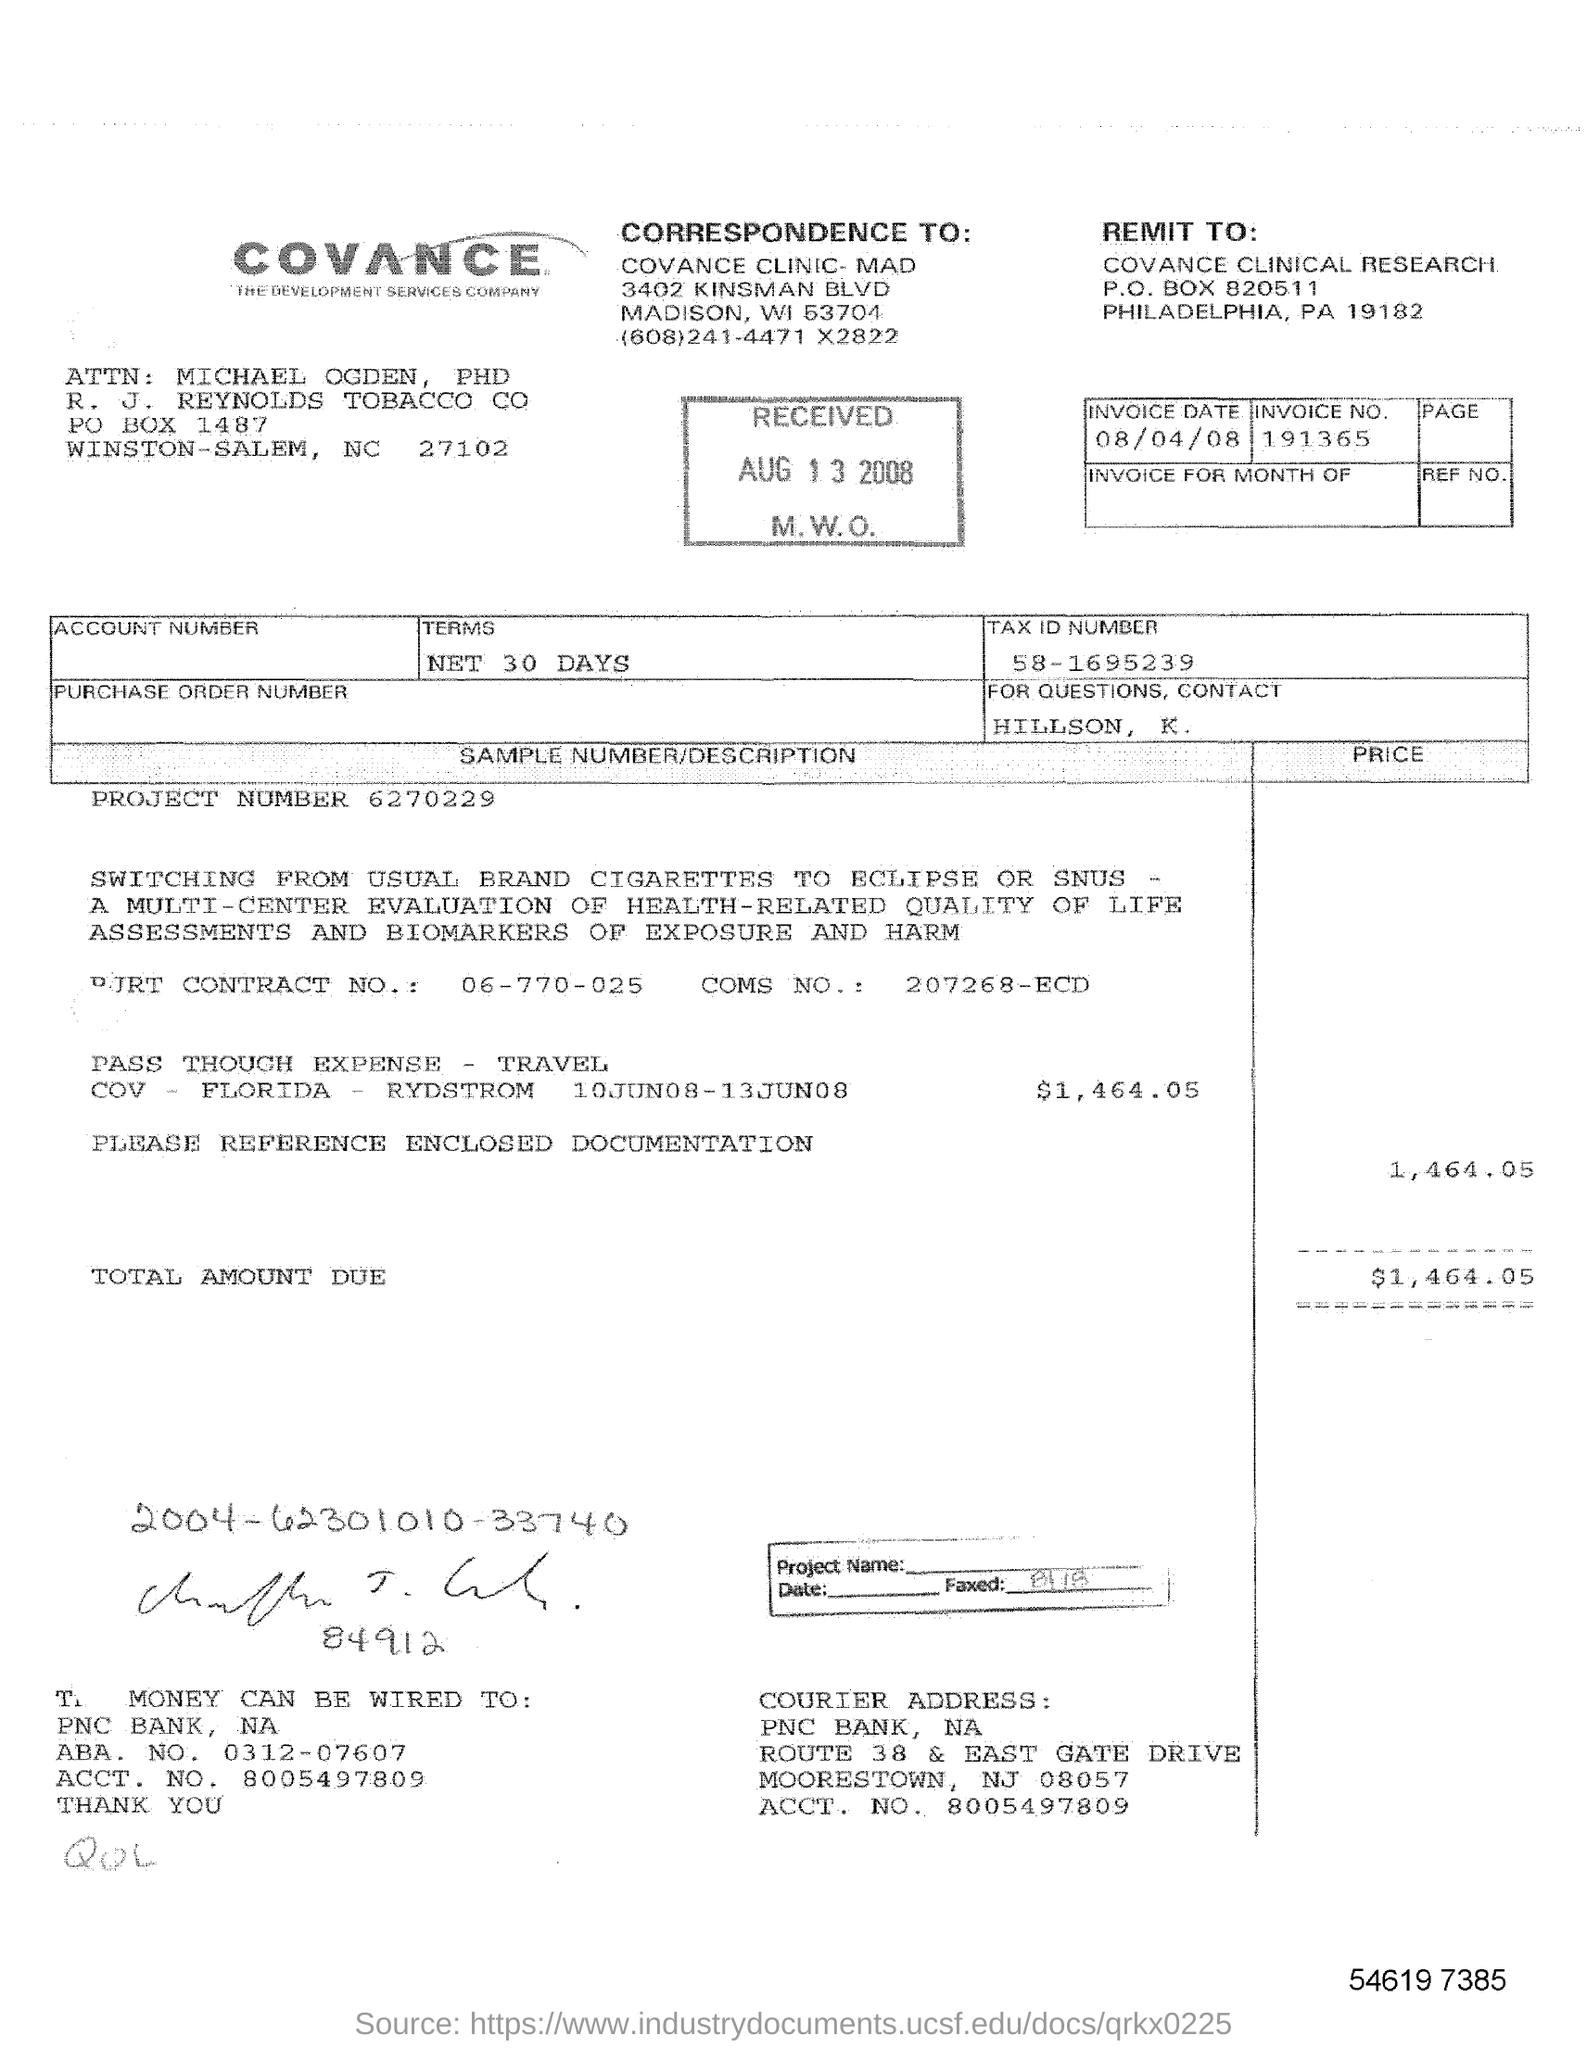Whom to contact, if there are any queries?
Give a very brief answer. Hillson, K. What is the date on the bill invoice?
Provide a short and direct response. 08/04/08. How much is the total travel expense?
Offer a very short reply. $1,464.05. To Which bank money can be wired ?
Offer a very short reply. PNC bank. As per the stamp, what is the received date?
Give a very brief answer. AUG 13 2008. What is the project number?
Your response must be concise. 6270229. What is the invoice no.?
Ensure brevity in your answer.  191365. 